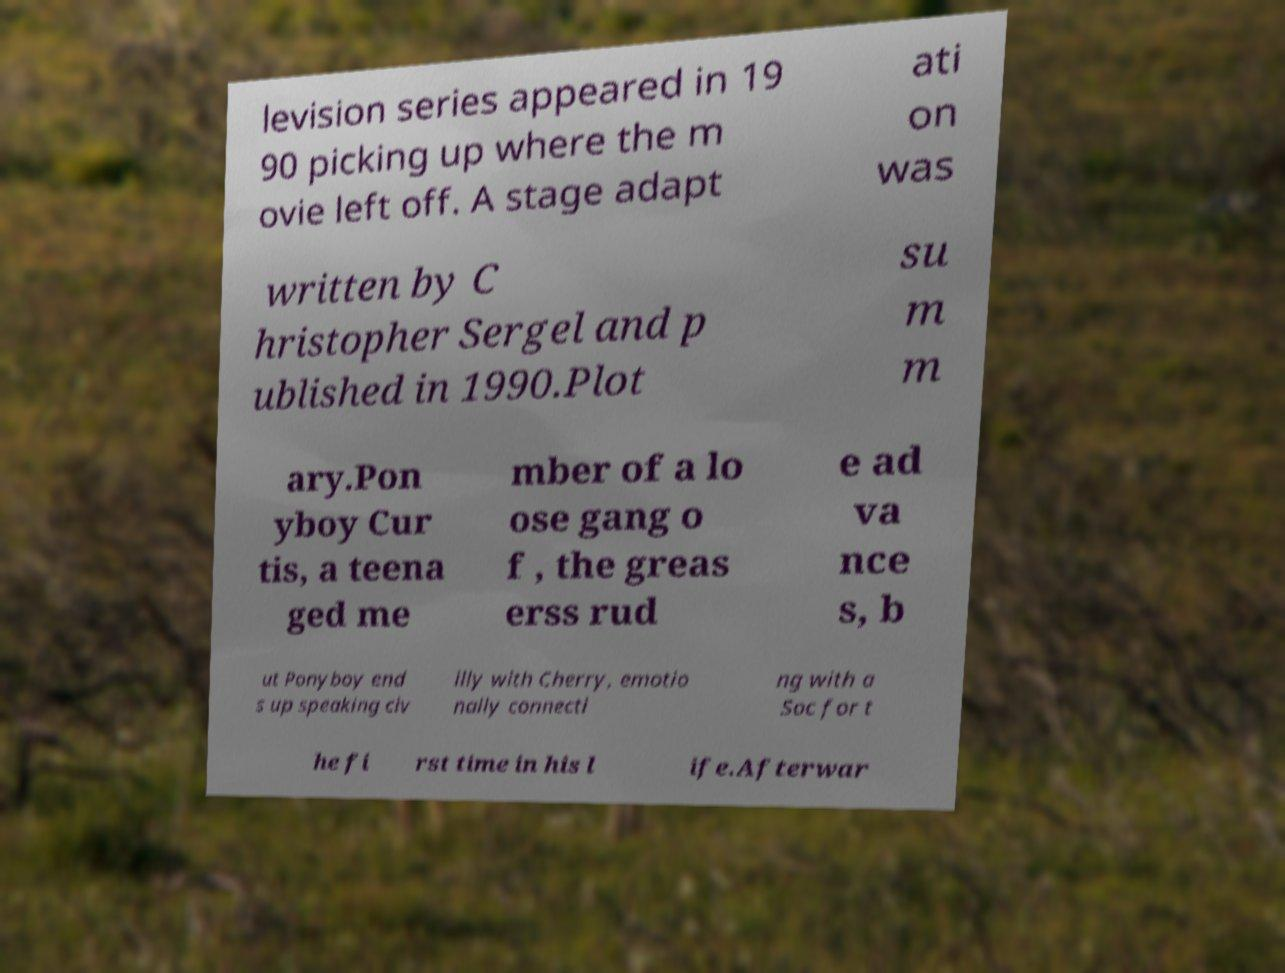There's text embedded in this image that I need extracted. Can you transcribe it verbatim? levision series appeared in 19 90 picking up where the m ovie left off. A stage adapt ati on was written by C hristopher Sergel and p ublished in 1990.Plot su m m ary.Pon yboy Cur tis, a teena ged me mber of a lo ose gang o f , the greas erss rud e ad va nce s, b ut Ponyboy end s up speaking civ illy with Cherry, emotio nally connecti ng with a Soc for t he fi rst time in his l ife.Afterwar 